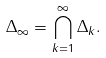Convert formula to latex. <formula><loc_0><loc_0><loc_500><loc_500>\Delta _ { \infty } = \bigcap _ { k = 1 } ^ { \infty } \Delta _ { k } .</formula> 